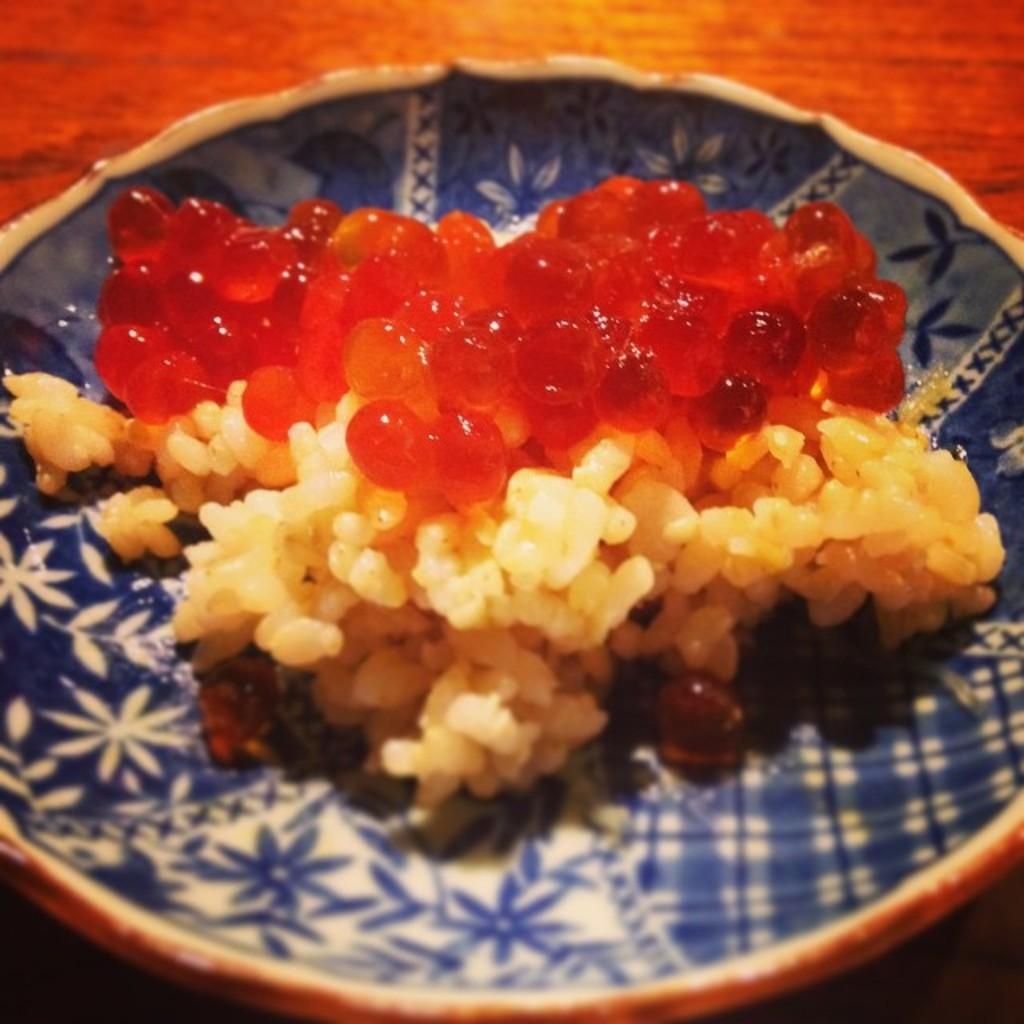What is present on the wooden surface in the image? There is a plate in the image. What is on the plate? There is food on the plate. What type of veil can be seen covering the food on the plate? There is no veil present in the image; the food is visible on the plate. 